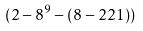<formula> <loc_0><loc_0><loc_500><loc_500>( 2 - 8 ^ { 9 } - ( 8 - 2 2 1 ) )</formula> 